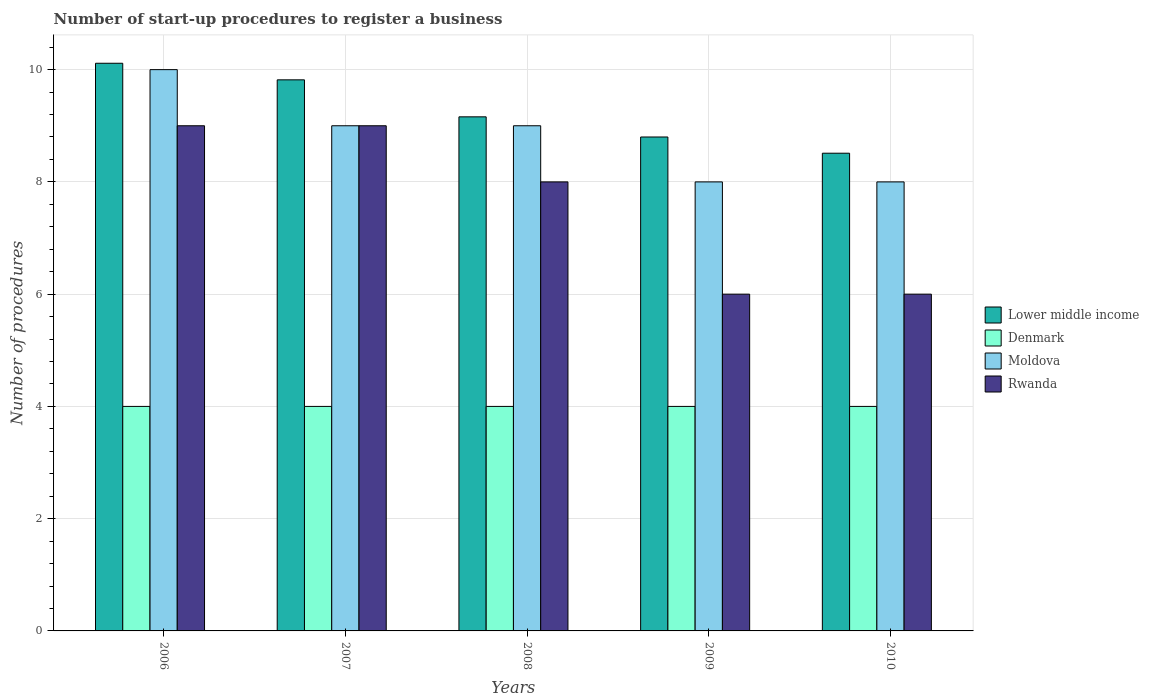How many different coloured bars are there?
Provide a succinct answer. 4. Are the number of bars per tick equal to the number of legend labels?
Your response must be concise. Yes. How many bars are there on the 2nd tick from the left?
Ensure brevity in your answer.  4. How many bars are there on the 1st tick from the right?
Offer a very short reply. 4. What is the label of the 5th group of bars from the left?
Your answer should be compact. 2010. What is the number of procedures required to register a business in Denmark in 2007?
Give a very brief answer. 4. Across all years, what is the maximum number of procedures required to register a business in Lower middle income?
Ensure brevity in your answer.  10.11. Across all years, what is the minimum number of procedures required to register a business in Moldova?
Ensure brevity in your answer.  8. In which year was the number of procedures required to register a business in Lower middle income maximum?
Offer a terse response. 2006. What is the total number of procedures required to register a business in Lower middle income in the graph?
Offer a terse response. 46.4. What is the difference between the number of procedures required to register a business in Rwanda in 2007 and that in 2009?
Your answer should be very brief. 3. What is the difference between the number of procedures required to register a business in Lower middle income in 2008 and the number of procedures required to register a business in Moldova in 2009?
Offer a very short reply. 1.16. What is the average number of procedures required to register a business in Moldova per year?
Offer a terse response. 8.8. In the year 2009, what is the difference between the number of procedures required to register a business in Moldova and number of procedures required to register a business in Rwanda?
Offer a very short reply. 2. In how many years, is the number of procedures required to register a business in Rwanda greater than 9.6?
Your answer should be compact. 0. What is the ratio of the number of procedures required to register a business in Denmark in 2006 to that in 2009?
Keep it short and to the point. 1. Is the number of procedures required to register a business in Lower middle income in 2006 less than that in 2010?
Give a very brief answer. No. In how many years, is the number of procedures required to register a business in Rwanda greater than the average number of procedures required to register a business in Rwanda taken over all years?
Make the answer very short. 3. What does the 3rd bar from the left in 2007 represents?
Keep it short and to the point. Moldova. What does the 3rd bar from the right in 2008 represents?
Give a very brief answer. Denmark. Is it the case that in every year, the sum of the number of procedures required to register a business in Lower middle income and number of procedures required to register a business in Rwanda is greater than the number of procedures required to register a business in Denmark?
Provide a short and direct response. Yes. How many bars are there?
Make the answer very short. 20. Are all the bars in the graph horizontal?
Provide a succinct answer. No. What is the difference between two consecutive major ticks on the Y-axis?
Your response must be concise. 2. Does the graph contain grids?
Your response must be concise. Yes. Where does the legend appear in the graph?
Your answer should be compact. Center right. How are the legend labels stacked?
Ensure brevity in your answer.  Vertical. What is the title of the graph?
Make the answer very short. Number of start-up procedures to register a business. Does "Luxembourg" appear as one of the legend labels in the graph?
Your answer should be very brief. No. What is the label or title of the X-axis?
Your answer should be compact. Years. What is the label or title of the Y-axis?
Offer a terse response. Number of procedures. What is the Number of procedures in Lower middle income in 2006?
Your answer should be compact. 10.11. What is the Number of procedures of Denmark in 2006?
Your answer should be very brief. 4. What is the Number of procedures in Rwanda in 2006?
Keep it short and to the point. 9. What is the Number of procedures in Lower middle income in 2007?
Make the answer very short. 9.82. What is the Number of procedures of Moldova in 2007?
Provide a short and direct response. 9. What is the Number of procedures of Rwanda in 2007?
Provide a short and direct response. 9. What is the Number of procedures of Lower middle income in 2008?
Your response must be concise. 9.16. What is the Number of procedures in Denmark in 2008?
Your answer should be compact. 4. What is the Number of procedures in Moldova in 2008?
Offer a very short reply. 9. What is the Number of procedures of Rwanda in 2008?
Your answer should be compact. 8. What is the Number of procedures of Denmark in 2009?
Offer a terse response. 4. What is the Number of procedures in Lower middle income in 2010?
Your answer should be compact. 8.51. What is the Number of procedures in Moldova in 2010?
Your answer should be very brief. 8. Across all years, what is the maximum Number of procedures in Lower middle income?
Make the answer very short. 10.11. Across all years, what is the maximum Number of procedures in Denmark?
Ensure brevity in your answer.  4. Across all years, what is the minimum Number of procedures of Lower middle income?
Offer a terse response. 8.51. Across all years, what is the minimum Number of procedures of Denmark?
Offer a very short reply. 4. What is the total Number of procedures of Lower middle income in the graph?
Provide a short and direct response. 46.4. What is the difference between the Number of procedures of Lower middle income in 2006 and that in 2007?
Provide a succinct answer. 0.3. What is the difference between the Number of procedures of Lower middle income in 2006 and that in 2008?
Offer a terse response. 0.95. What is the difference between the Number of procedures in Denmark in 2006 and that in 2008?
Your answer should be compact. 0. What is the difference between the Number of procedures in Moldova in 2006 and that in 2008?
Offer a very short reply. 1. What is the difference between the Number of procedures in Rwanda in 2006 and that in 2008?
Your answer should be compact. 1. What is the difference between the Number of procedures of Lower middle income in 2006 and that in 2009?
Keep it short and to the point. 1.31. What is the difference between the Number of procedures of Moldova in 2006 and that in 2009?
Make the answer very short. 2. What is the difference between the Number of procedures of Rwanda in 2006 and that in 2009?
Your answer should be very brief. 3. What is the difference between the Number of procedures in Lower middle income in 2006 and that in 2010?
Offer a very short reply. 1.6. What is the difference between the Number of procedures of Denmark in 2006 and that in 2010?
Your response must be concise. 0. What is the difference between the Number of procedures in Moldova in 2006 and that in 2010?
Ensure brevity in your answer.  2. What is the difference between the Number of procedures in Rwanda in 2006 and that in 2010?
Offer a terse response. 3. What is the difference between the Number of procedures in Lower middle income in 2007 and that in 2008?
Provide a short and direct response. 0.66. What is the difference between the Number of procedures in Rwanda in 2007 and that in 2008?
Ensure brevity in your answer.  1. What is the difference between the Number of procedures of Lower middle income in 2007 and that in 2009?
Ensure brevity in your answer.  1.02. What is the difference between the Number of procedures in Denmark in 2007 and that in 2009?
Provide a succinct answer. 0. What is the difference between the Number of procedures of Moldova in 2007 and that in 2009?
Your response must be concise. 1. What is the difference between the Number of procedures of Rwanda in 2007 and that in 2009?
Your answer should be very brief. 3. What is the difference between the Number of procedures in Lower middle income in 2007 and that in 2010?
Your answer should be very brief. 1.31. What is the difference between the Number of procedures in Rwanda in 2007 and that in 2010?
Offer a terse response. 3. What is the difference between the Number of procedures of Lower middle income in 2008 and that in 2009?
Provide a short and direct response. 0.36. What is the difference between the Number of procedures in Moldova in 2008 and that in 2009?
Give a very brief answer. 1. What is the difference between the Number of procedures in Rwanda in 2008 and that in 2009?
Offer a terse response. 2. What is the difference between the Number of procedures in Lower middle income in 2008 and that in 2010?
Your answer should be very brief. 0.65. What is the difference between the Number of procedures in Denmark in 2008 and that in 2010?
Offer a terse response. 0. What is the difference between the Number of procedures in Rwanda in 2008 and that in 2010?
Your response must be concise. 2. What is the difference between the Number of procedures in Lower middle income in 2009 and that in 2010?
Offer a terse response. 0.29. What is the difference between the Number of procedures of Denmark in 2009 and that in 2010?
Your response must be concise. 0. What is the difference between the Number of procedures of Rwanda in 2009 and that in 2010?
Provide a short and direct response. 0. What is the difference between the Number of procedures in Lower middle income in 2006 and the Number of procedures in Denmark in 2007?
Your answer should be compact. 6.11. What is the difference between the Number of procedures in Lower middle income in 2006 and the Number of procedures in Moldova in 2007?
Provide a short and direct response. 1.11. What is the difference between the Number of procedures of Lower middle income in 2006 and the Number of procedures of Rwanda in 2007?
Ensure brevity in your answer.  1.11. What is the difference between the Number of procedures in Denmark in 2006 and the Number of procedures in Moldova in 2007?
Your answer should be compact. -5. What is the difference between the Number of procedures in Lower middle income in 2006 and the Number of procedures in Denmark in 2008?
Make the answer very short. 6.11. What is the difference between the Number of procedures in Lower middle income in 2006 and the Number of procedures in Moldova in 2008?
Your answer should be compact. 1.11. What is the difference between the Number of procedures of Lower middle income in 2006 and the Number of procedures of Rwanda in 2008?
Your answer should be compact. 2.11. What is the difference between the Number of procedures in Denmark in 2006 and the Number of procedures in Moldova in 2008?
Keep it short and to the point. -5. What is the difference between the Number of procedures of Denmark in 2006 and the Number of procedures of Rwanda in 2008?
Give a very brief answer. -4. What is the difference between the Number of procedures in Moldova in 2006 and the Number of procedures in Rwanda in 2008?
Your answer should be very brief. 2. What is the difference between the Number of procedures in Lower middle income in 2006 and the Number of procedures in Denmark in 2009?
Your answer should be very brief. 6.11. What is the difference between the Number of procedures in Lower middle income in 2006 and the Number of procedures in Moldova in 2009?
Make the answer very short. 2.11. What is the difference between the Number of procedures in Lower middle income in 2006 and the Number of procedures in Rwanda in 2009?
Offer a terse response. 4.11. What is the difference between the Number of procedures in Denmark in 2006 and the Number of procedures in Rwanda in 2009?
Provide a succinct answer. -2. What is the difference between the Number of procedures in Moldova in 2006 and the Number of procedures in Rwanda in 2009?
Give a very brief answer. 4. What is the difference between the Number of procedures of Lower middle income in 2006 and the Number of procedures of Denmark in 2010?
Your answer should be very brief. 6.11. What is the difference between the Number of procedures in Lower middle income in 2006 and the Number of procedures in Moldova in 2010?
Offer a very short reply. 2.11. What is the difference between the Number of procedures in Lower middle income in 2006 and the Number of procedures in Rwanda in 2010?
Make the answer very short. 4.11. What is the difference between the Number of procedures in Moldova in 2006 and the Number of procedures in Rwanda in 2010?
Provide a short and direct response. 4. What is the difference between the Number of procedures in Lower middle income in 2007 and the Number of procedures in Denmark in 2008?
Your response must be concise. 5.82. What is the difference between the Number of procedures in Lower middle income in 2007 and the Number of procedures in Moldova in 2008?
Give a very brief answer. 0.82. What is the difference between the Number of procedures in Lower middle income in 2007 and the Number of procedures in Rwanda in 2008?
Offer a terse response. 1.82. What is the difference between the Number of procedures in Denmark in 2007 and the Number of procedures in Moldova in 2008?
Offer a very short reply. -5. What is the difference between the Number of procedures of Lower middle income in 2007 and the Number of procedures of Denmark in 2009?
Make the answer very short. 5.82. What is the difference between the Number of procedures of Lower middle income in 2007 and the Number of procedures of Moldova in 2009?
Provide a short and direct response. 1.82. What is the difference between the Number of procedures in Lower middle income in 2007 and the Number of procedures in Rwanda in 2009?
Offer a terse response. 3.82. What is the difference between the Number of procedures of Denmark in 2007 and the Number of procedures of Moldova in 2009?
Your response must be concise. -4. What is the difference between the Number of procedures of Denmark in 2007 and the Number of procedures of Rwanda in 2009?
Make the answer very short. -2. What is the difference between the Number of procedures of Lower middle income in 2007 and the Number of procedures of Denmark in 2010?
Provide a short and direct response. 5.82. What is the difference between the Number of procedures in Lower middle income in 2007 and the Number of procedures in Moldova in 2010?
Your answer should be compact. 1.82. What is the difference between the Number of procedures of Lower middle income in 2007 and the Number of procedures of Rwanda in 2010?
Offer a terse response. 3.82. What is the difference between the Number of procedures of Denmark in 2007 and the Number of procedures of Moldova in 2010?
Offer a terse response. -4. What is the difference between the Number of procedures of Moldova in 2007 and the Number of procedures of Rwanda in 2010?
Provide a short and direct response. 3. What is the difference between the Number of procedures of Lower middle income in 2008 and the Number of procedures of Denmark in 2009?
Make the answer very short. 5.16. What is the difference between the Number of procedures of Lower middle income in 2008 and the Number of procedures of Moldova in 2009?
Ensure brevity in your answer.  1.16. What is the difference between the Number of procedures of Lower middle income in 2008 and the Number of procedures of Rwanda in 2009?
Offer a terse response. 3.16. What is the difference between the Number of procedures of Denmark in 2008 and the Number of procedures of Moldova in 2009?
Give a very brief answer. -4. What is the difference between the Number of procedures in Denmark in 2008 and the Number of procedures in Rwanda in 2009?
Offer a terse response. -2. What is the difference between the Number of procedures in Lower middle income in 2008 and the Number of procedures in Denmark in 2010?
Keep it short and to the point. 5.16. What is the difference between the Number of procedures of Lower middle income in 2008 and the Number of procedures of Moldova in 2010?
Ensure brevity in your answer.  1.16. What is the difference between the Number of procedures of Lower middle income in 2008 and the Number of procedures of Rwanda in 2010?
Provide a succinct answer. 3.16. What is the difference between the Number of procedures of Denmark in 2008 and the Number of procedures of Moldova in 2010?
Your answer should be very brief. -4. What is the difference between the Number of procedures in Lower middle income in 2009 and the Number of procedures in Rwanda in 2010?
Give a very brief answer. 2.8. What is the difference between the Number of procedures of Denmark in 2009 and the Number of procedures of Rwanda in 2010?
Your answer should be very brief. -2. What is the difference between the Number of procedures in Moldova in 2009 and the Number of procedures in Rwanda in 2010?
Offer a terse response. 2. What is the average Number of procedures of Lower middle income per year?
Ensure brevity in your answer.  9.28. What is the average Number of procedures in Denmark per year?
Offer a terse response. 4. What is the average Number of procedures of Moldova per year?
Make the answer very short. 8.8. What is the average Number of procedures in Rwanda per year?
Offer a very short reply. 7.6. In the year 2006, what is the difference between the Number of procedures in Lower middle income and Number of procedures in Denmark?
Offer a very short reply. 6.11. In the year 2006, what is the difference between the Number of procedures of Lower middle income and Number of procedures of Moldova?
Ensure brevity in your answer.  0.11. In the year 2006, what is the difference between the Number of procedures of Lower middle income and Number of procedures of Rwanda?
Provide a short and direct response. 1.11. In the year 2006, what is the difference between the Number of procedures of Denmark and Number of procedures of Moldova?
Offer a very short reply. -6. In the year 2006, what is the difference between the Number of procedures in Denmark and Number of procedures in Rwanda?
Offer a very short reply. -5. In the year 2006, what is the difference between the Number of procedures in Moldova and Number of procedures in Rwanda?
Provide a short and direct response. 1. In the year 2007, what is the difference between the Number of procedures in Lower middle income and Number of procedures in Denmark?
Provide a short and direct response. 5.82. In the year 2007, what is the difference between the Number of procedures in Lower middle income and Number of procedures in Moldova?
Provide a succinct answer. 0.82. In the year 2007, what is the difference between the Number of procedures in Lower middle income and Number of procedures in Rwanda?
Provide a succinct answer. 0.82. In the year 2008, what is the difference between the Number of procedures of Lower middle income and Number of procedures of Denmark?
Give a very brief answer. 5.16. In the year 2008, what is the difference between the Number of procedures of Lower middle income and Number of procedures of Moldova?
Your answer should be compact. 0.16. In the year 2008, what is the difference between the Number of procedures in Lower middle income and Number of procedures in Rwanda?
Make the answer very short. 1.16. In the year 2008, what is the difference between the Number of procedures of Denmark and Number of procedures of Moldova?
Your answer should be very brief. -5. In the year 2008, what is the difference between the Number of procedures of Denmark and Number of procedures of Rwanda?
Make the answer very short. -4. In the year 2009, what is the difference between the Number of procedures of Lower middle income and Number of procedures of Denmark?
Provide a succinct answer. 4.8. In the year 2009, what is the difference between the Number of procedures of Lower middle income and Number of procedures of Moldova?
Your answer should be very brief. 0.8. In the year 2009, what is the difference between the Number of procedures in Lower middle income and Number of procedures in Rwanda?
Offer a terse response. 2.8. In the year 2010, what is the difference between the Number of procedures of Lower middle income and Number of procedures of Denmark?
Provide a short and direct response. 4.51. In the year 2010, what is the difference between the Number of procedures in Lower middle income and Number of procedures in Moldova?
Your answer should be very brief. 0.51. In the year 2010, what is the difference between the Number of procedures of Lower middle income and Number of procedures of Rwanda?
Keep it short and to the point. 2.51. What is the ratio of the Number of procedures of Lower middle income in 2006 to that in 2007?
Offer a very short reply. 1.03. What is the ratio of the Number of procedures of Moldova in 2006 to that in 2007?
Provide a short and direct response. 1.11. What is the ratio of the Number of procedures in Lower middle income in 2006 to that in 2008?
Provide a short and direct response. 1.1. What is the ratio of the Number of procedures of Denmark in 2006 to that in 2008?
Your answer should be compact. 1. What is the ratio of the Number of procedures of Moldova in 2006 to that in 2008?
Provide a succinct answer. 1.11. What is the ratio of the Number of procedures in Lower middle income in 2006 to that in 2009?
Provide a succinct answer. 1.15. What is the ratio of the Number of procedures of Moldova in 2006 to that in 2009?
Keep it short and to the point. 1.25. What is the ratio of the Number of procedures in Lower middle income in 2006 to that in 2010?
Keep it short and to the point. 1.19. What is the ratio of the Number of procedures in Denmark in 2006 to that in 2010?
Offer a terse response. 1. What is the ratio of the Number of procedures of Rwanda in 2006 to that in 2010?
Provide a short and direct response. 1.5. What is the ratio of the Number of procedures in Lower middle income in 2007 to that in 2008?
Offer a terse response. 1.07. What is the ratio of the Number of procedures of Denmark in 2007 to that in 2008?
Ensure brevity in your answer.  1. What is the ratio of the Number of procedures in Moldova in 2007 to that in 2008?
Give a very brief answer. 1. What is the ratio of the Number of procedures in Lower middle income in 2007 to that in 2009?
Offer a very short reply. 1.12. What is the ratio of the Number of procedures of Moldova in 2007 to that in 2009?
Offer a very short reply. 1.12. What is the ratio of the Number of procedures of Lower middle income in 2007 to that in 2010?
Give a very brief answer. 1.15. What is the ratio of the Number of procedures in Denmark in 2007 to that in 2010?
Your answer should be compact. 1. What is the ratio of the Number of procedures in Moldova in 2007 to that in 2010?
Offer a very short reply. 1.12. What is the ratio of the Number of procedures of Lower middle income in 2008 to that in 2009?
Keep it short and to the point. 1.04. What is the ratio of the Number of procedures in Denmark in 2008 to that in 2009?
Offer a terse response. 1. What is the ratio of the Number of procedures of Moldova in 2008 to that in 2009?
Give a very brief answer. 1.12. What is the ratio of the Number of procedures of Lower middle income in 2008 to that in 2010?
Offer a very short reply. 1.08. What is the ratio of the Number of procedures in Lower middle income in 2009 to that in 2010?
Offer a terse response. 1.03. What is the ratio of the Number of procedures of Denmark in 2009 to that in 2010?
Offer a very short reply. 1. What is the difference between the highest and the second highest Number of procedures of Lower middle income?
Make the answer very short. 0.3. What is the difference between the highest and the second highest Number of procedures in Moldova?
Your response must be concise. 1. What is the difference between the highest and the lowest Number of procedures in Lower middle income?
Your answer should be very brief. 1.6. What is the difference between the highest and the lowest Number of procedures in Moldova?
Provide a succinct answer. 2. 